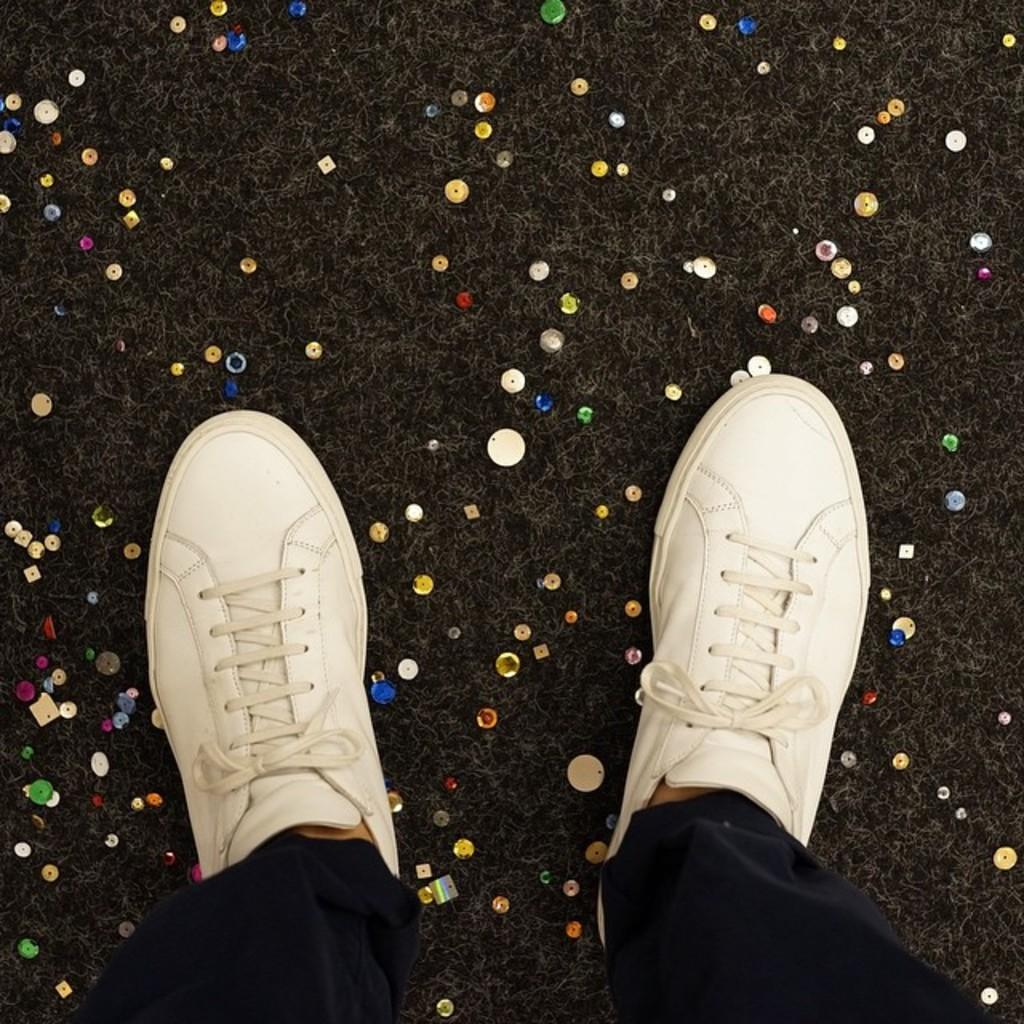What part of the person can be seen in the image? The person's legs are visible at the bottom of the image. What type of footwear is the person wearing? The person is wearing shoes. What type of clothing is the person wearing on their legs? The person is wearing pants. What can be seen in the background of the image? There is a carpet and decor in the background of the image. What type of glue is the person using to produce a painting in the image? There is no indication in the image that the person is using glue or producing a painting. 